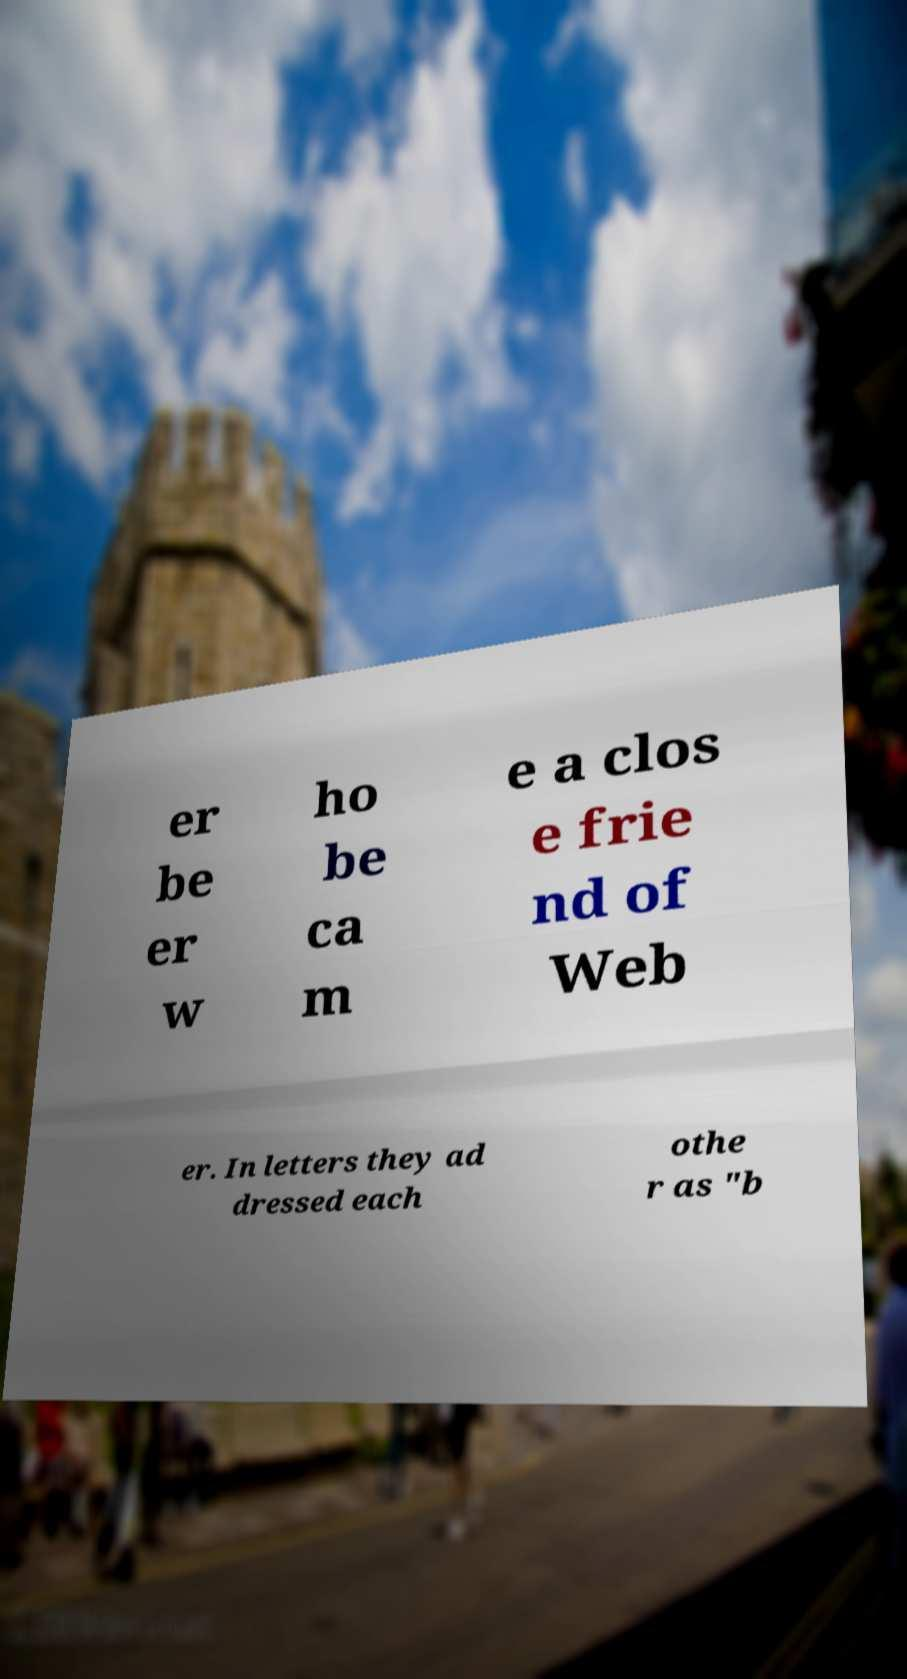Can you accurately transcribe the text from the provided image for me? er be er w ho be ca m e a clos e frie nd of Web er. In letters they ad dressed each othe r as "b 